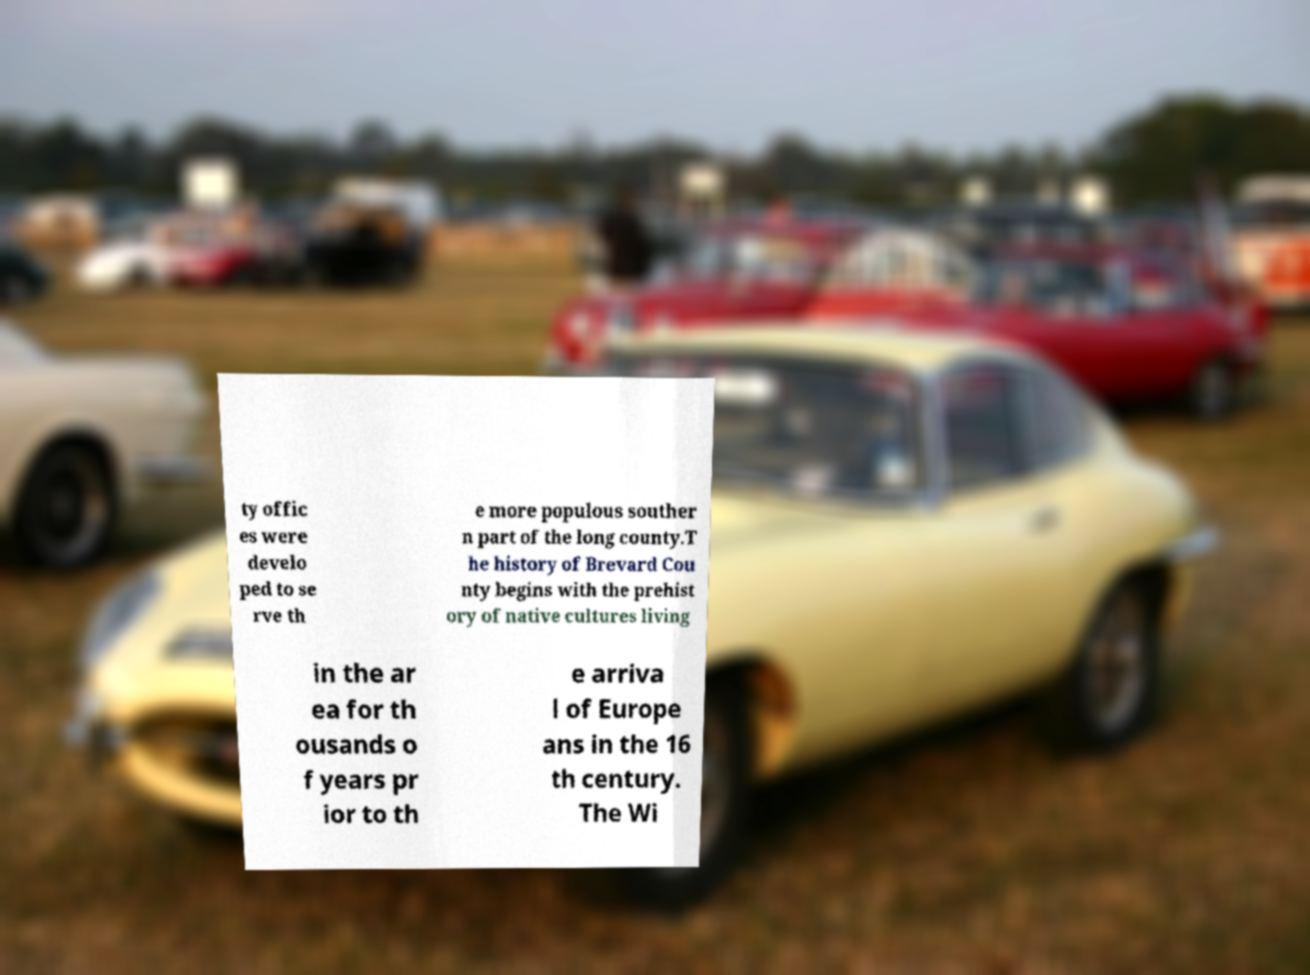There's text embedded in this image that I need extracted. Can you transcribe it verbatim? ty offic es were develo ped to se rve th e more populous souther n part of the long county.T he history of Brevard Cou nty begins with the prehist ory of native cultures living in the ar ea for th ousands o f years pr ior to th e arriva l of Europe ans in the 16 th century. The Wi 